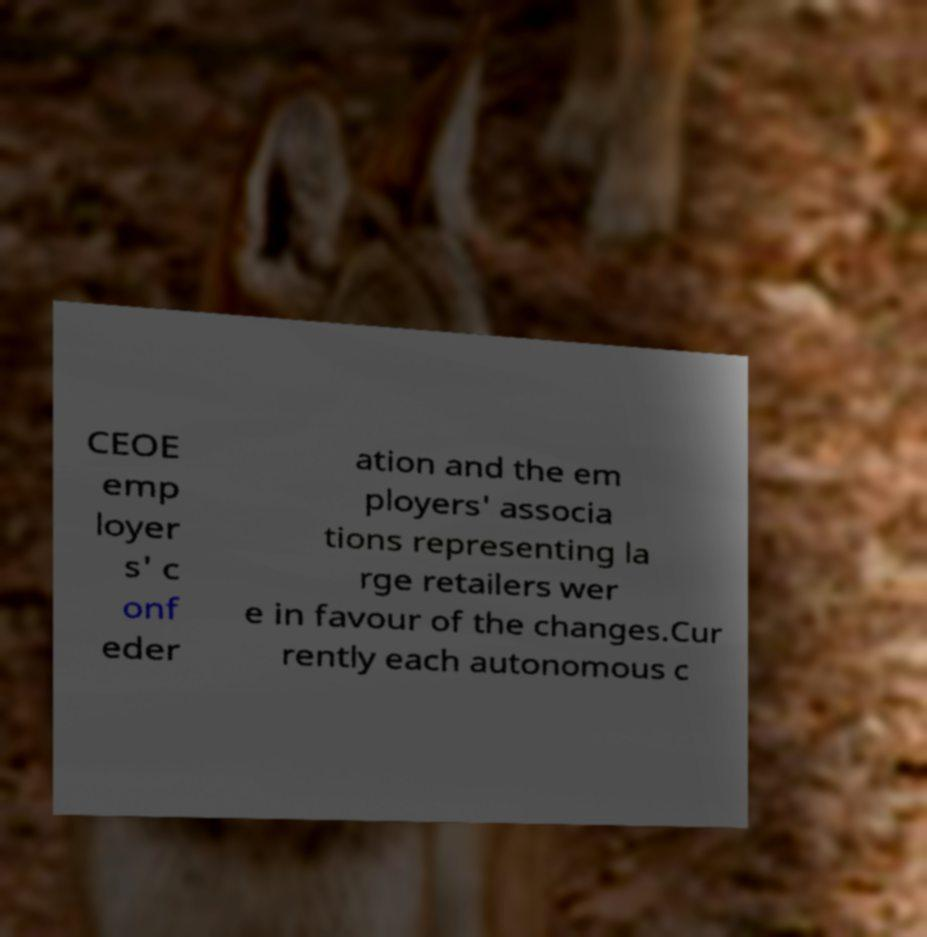There's text embedded in this image that I need extracted. Can you transcribe it verbatim? CEOE emp loyer s' c onf eder ation and the em ployers' associa tions representing la rge retailers wer e in favour of the changes.Cur rently each autonomous c 